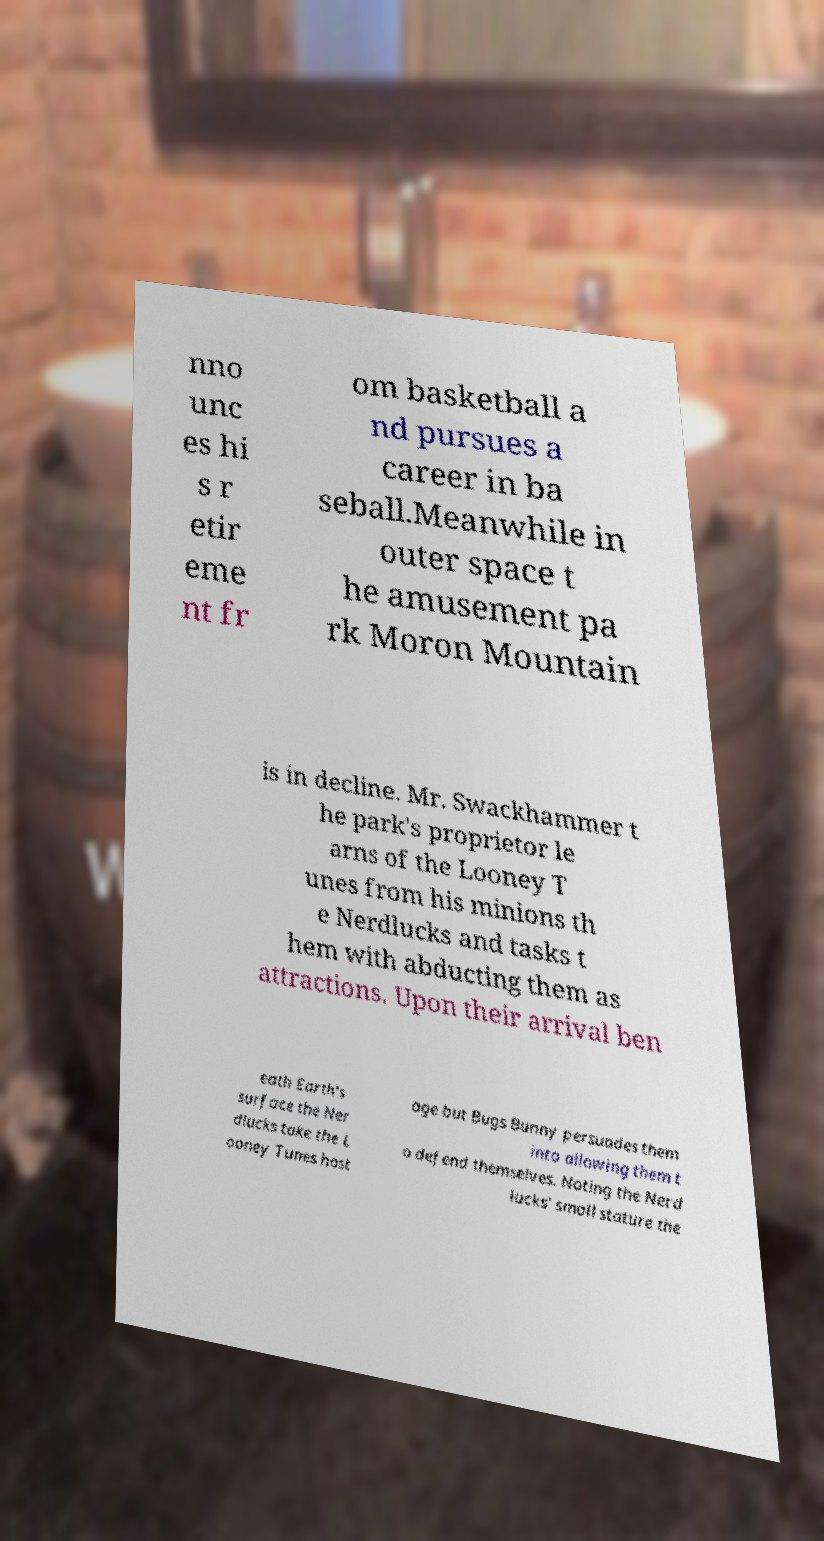Can you accurately transcribe the text from the provided image for me? nno unc es hi s r etir eme nt fr om basketball a nd pursues a career in ba seball.Meanwhile in outer space t he amusement pa rk Moron Mountain is in decline. Mr. Swackhammer t he park's proprietor le arns of the Looney T unes from his minions th e Nerdlucks and tasks t hem with abducting them as attractions. Upon their arrival ben eath Earth's surface the Ner dlucks take the L ooney Tunes host age but Bugs Bunny persuades them into allowing them t o defend themselves. Noting the Nerd lucks' small stature the 